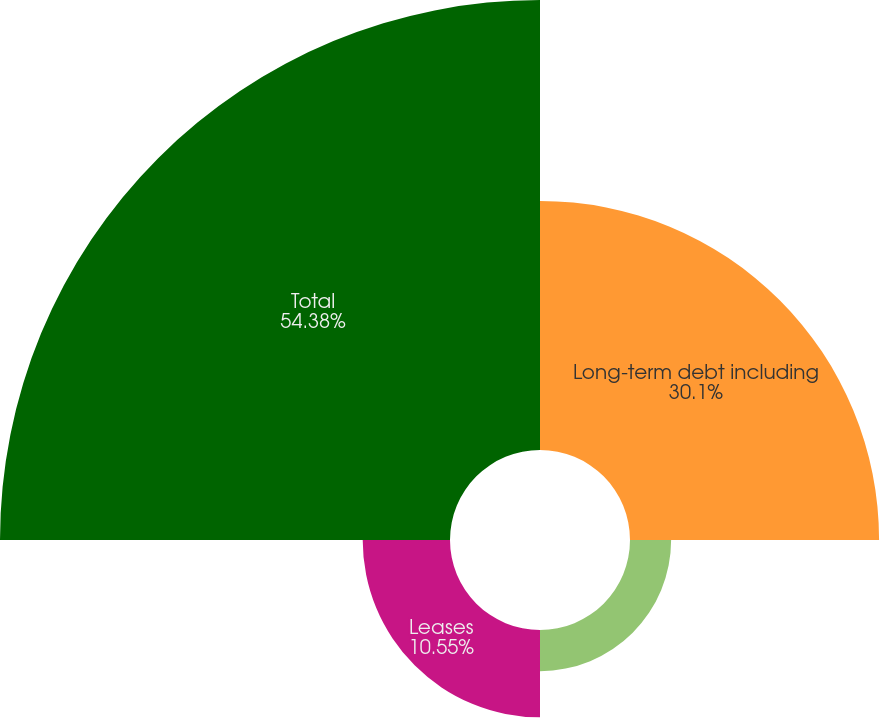Convert chart. <chart><loc_0><loc_0><loc_500><loc_500><pie_chart><fcel>Long-term debt including<fcel>Net cash interest payments on<fcel>Leases<fcel>Total<nl><fcel>30.1%<fcel>4.97%<fcel>10.55%<fcel>54.38%<nl></chart> 